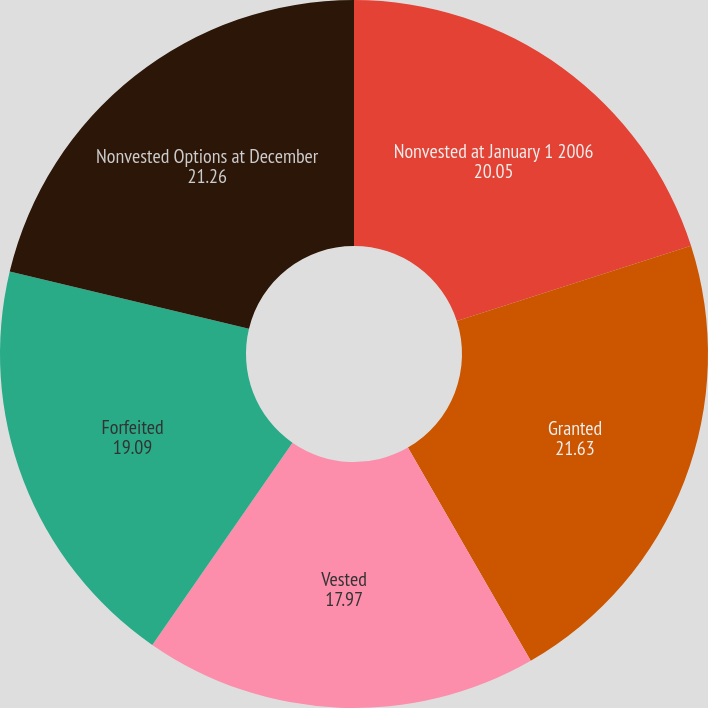Convert chart to OTSL. <chart><loc_0><loc_0><loc_500><loc_500><pie_chart><fcel>Nonvested at January 1 2006<fcel>Granted<fcel>Vested<fcel>Forfeited<fcel>Nonvested Options at December<nl><fcel>20.05%<fcel>21.63%<fcel>17.97%<fcel>19.09%<fcel>21.26%<nl></chart> 